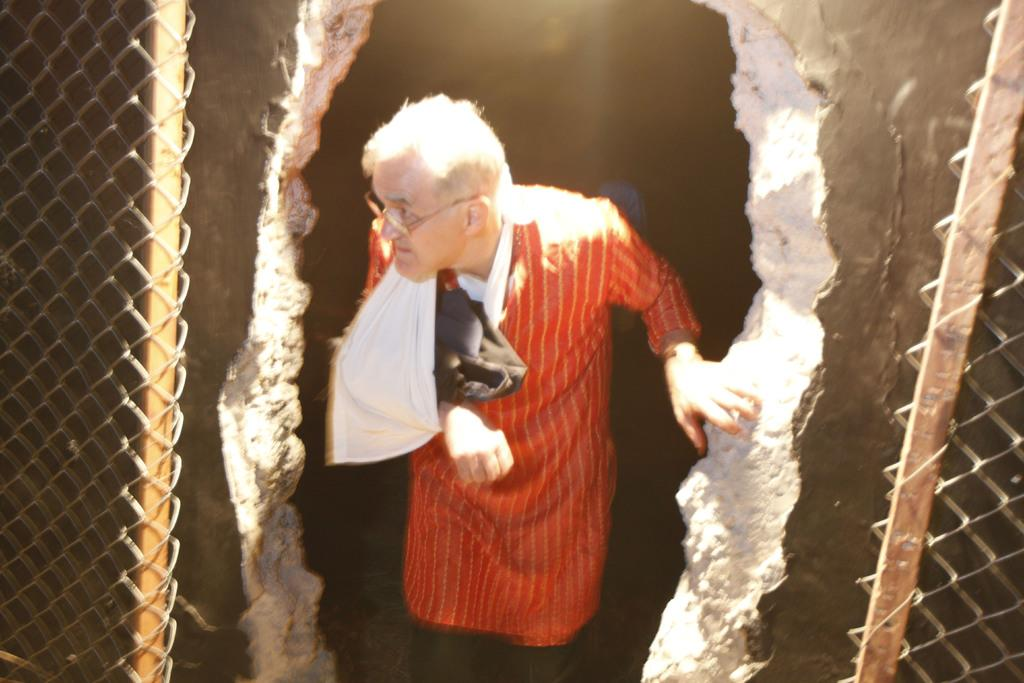What is the main subject of the image? There is a person standing in the center of the image. Where is the person standing? The person is standing on the floor. What can be seen on both sides of the image? Closed mesh fencing is present on both the right and left sides of the image. What type of drawer can be seen in the image? There is no drawer present in the image. How many zippers are visible on the person's body in the image? There is no mention of zippers or a person's body in the image; it only features a person standing on the floor with closed mesh fencing on both sides. 